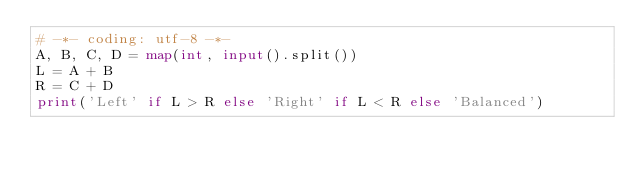Convert code to text. <code><loc_0><loc_0><loc_500><loc_500><_Python_># -*- coding: utf-8 -*-
A, B, C, D = map(int, input().split())
L = A + B
R = C + D
print('Left' if L > R else 'Right' if L < R else 'Balanced')</code> 